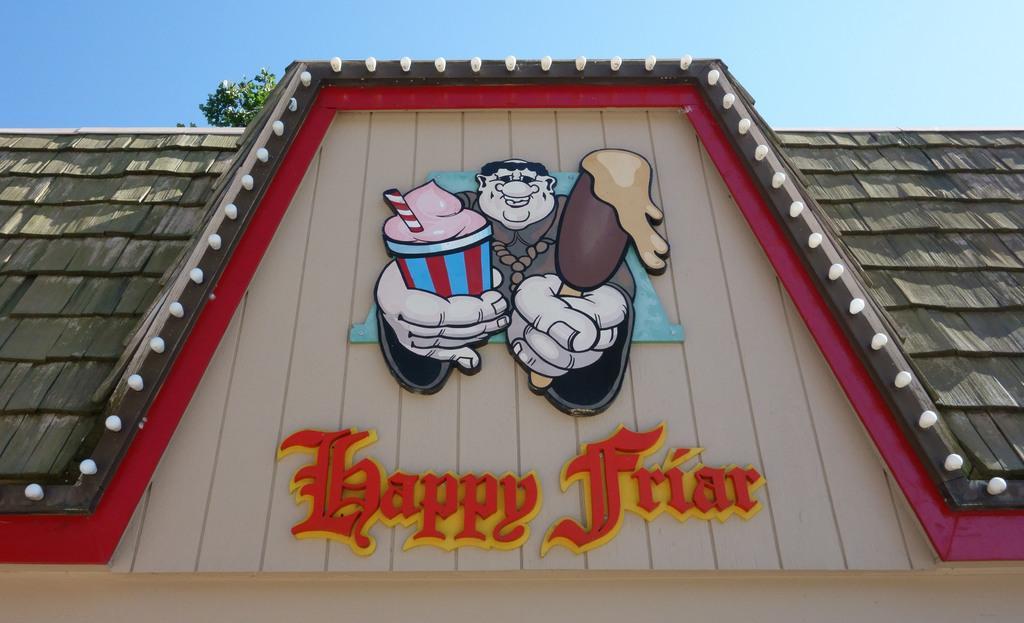How would you summarize this image in a sentence or two? In this picture we can see a rooftop with a sticker and a name on it, tree and in the background we can see the sky. 